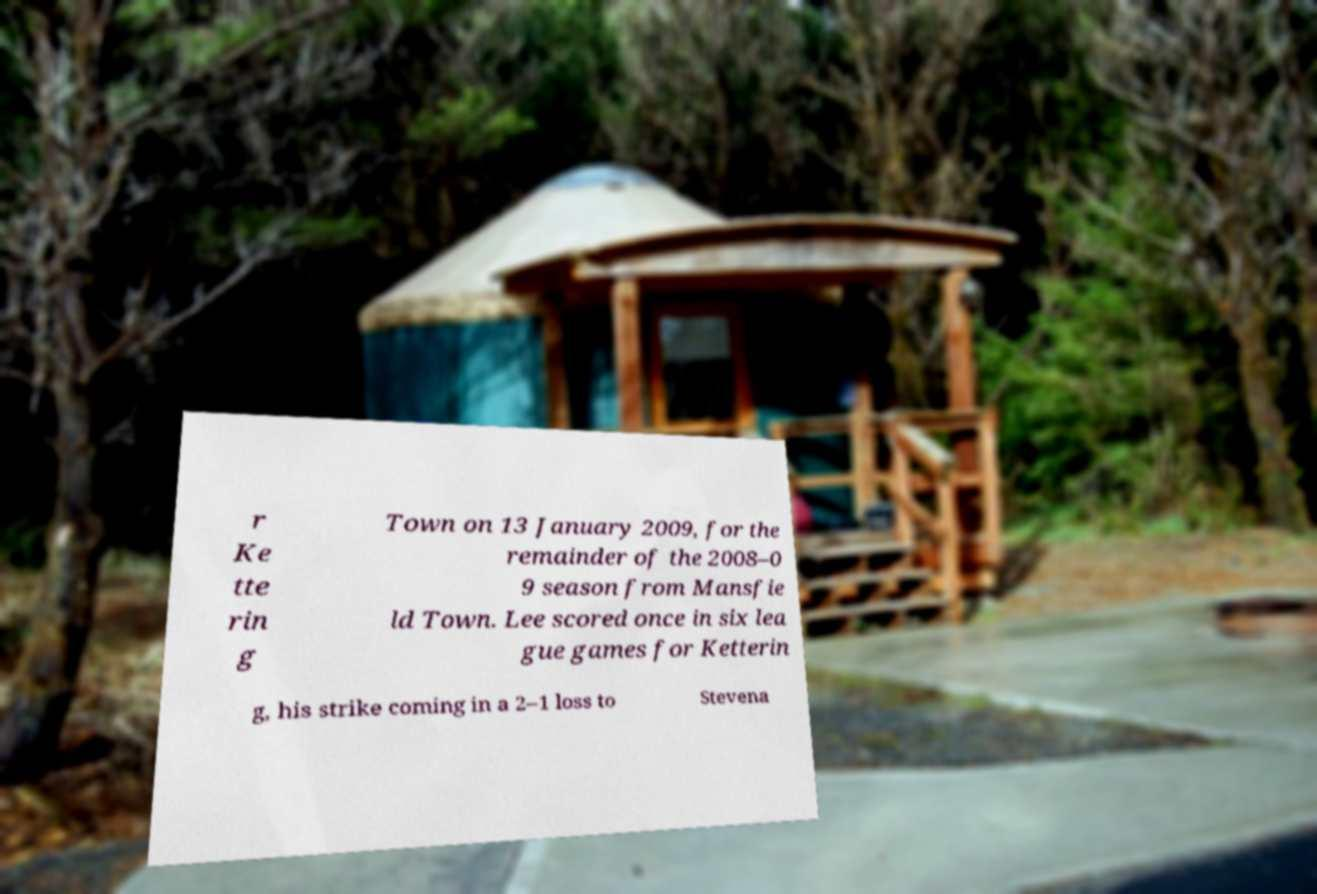I need the written content from this picture converted into text. Can you do that? r Ke tte rin g Town on 13 January 2009, for the remainder of the 2008–0 9 season from Mansfie ld Town. Lee scored once in six lea gue games for Ketterin g, his strike coming in a 2–1 loss to Stevena 